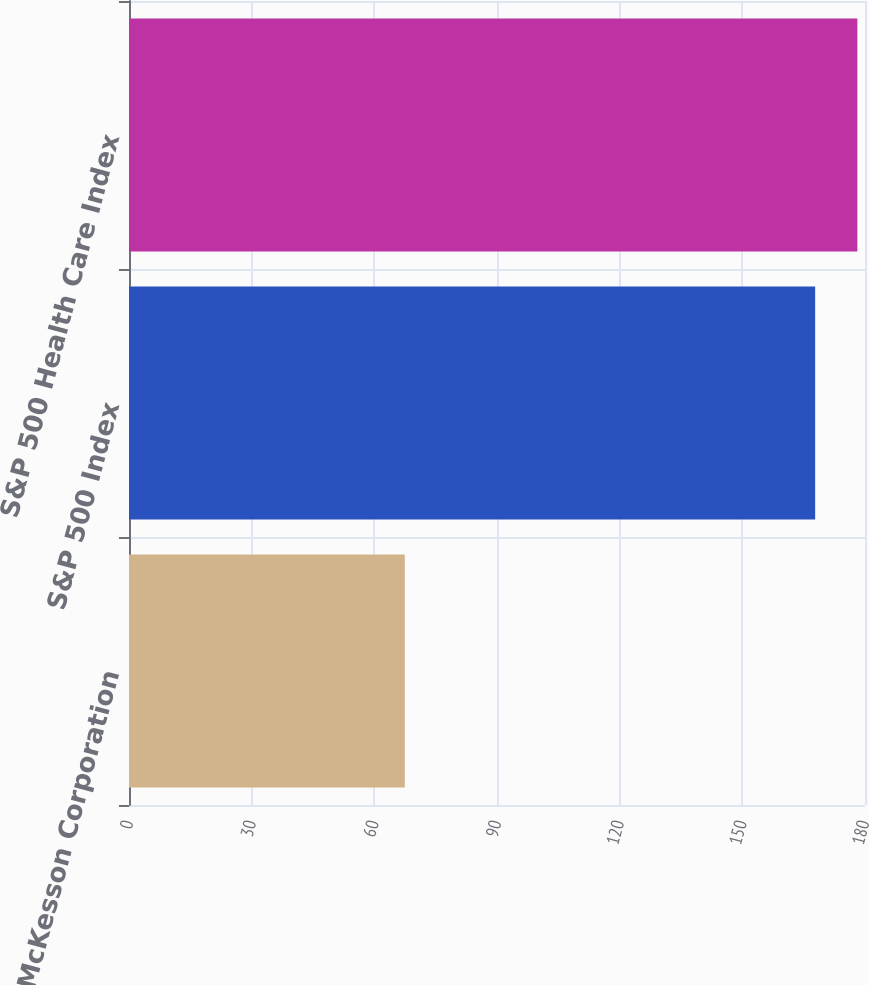<chart> <loc_0><loc_0><loc_500><loc_500><bar_chart><fcel>McKesson Corporation<fcel>S&P 500 Index<fcel>S&P 500 Health Care Index<nl><fcel>67.45<fcel>167.81<fcel>178.13<nl></chart> 